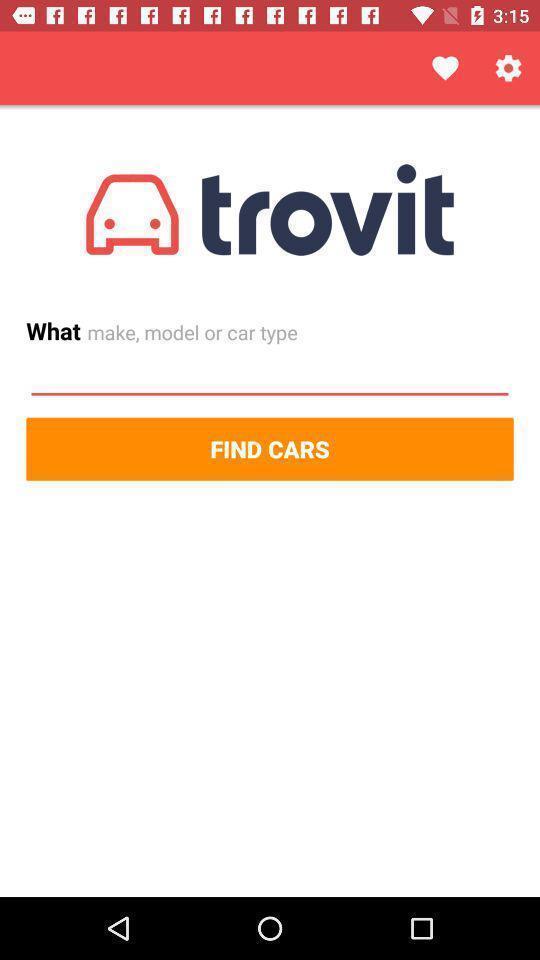Summarize the main components in this picture. Starting page. 